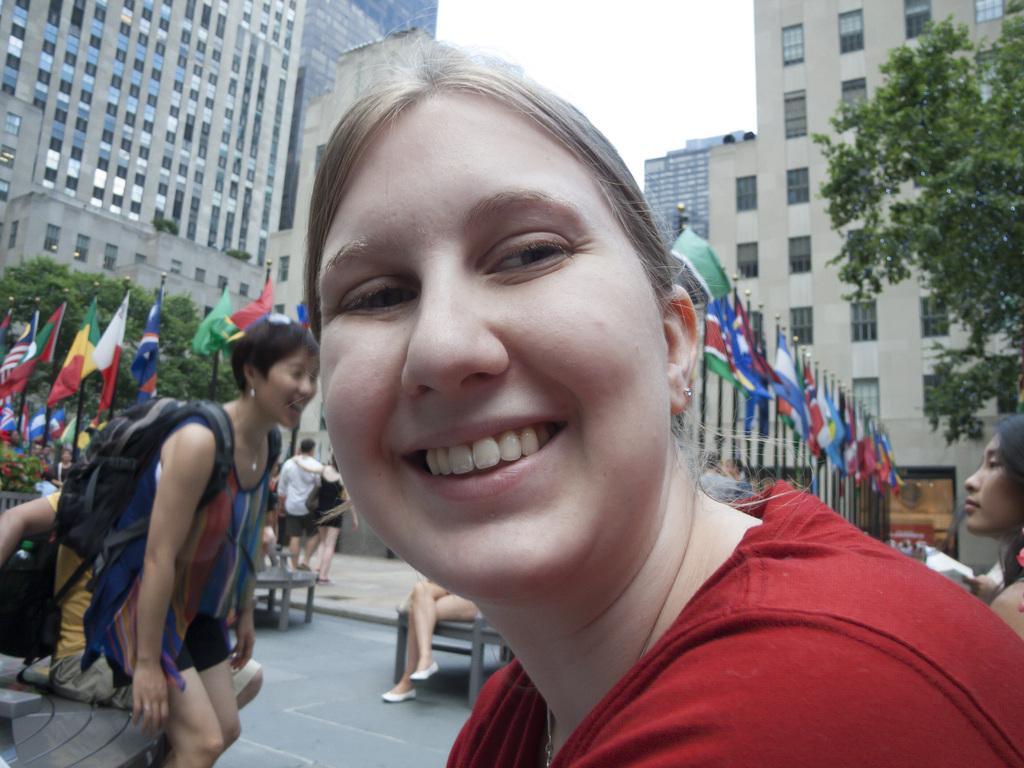In one or two sentences, can you explain what this image depicts? In this picture I can observe two women. Both of them are smiling. One of them is wearing red color T shirt. In the background there are some people. I can observe number of flags in the middle of the picture. On the right side there are trees. In the background I can observe buildings and sky. 